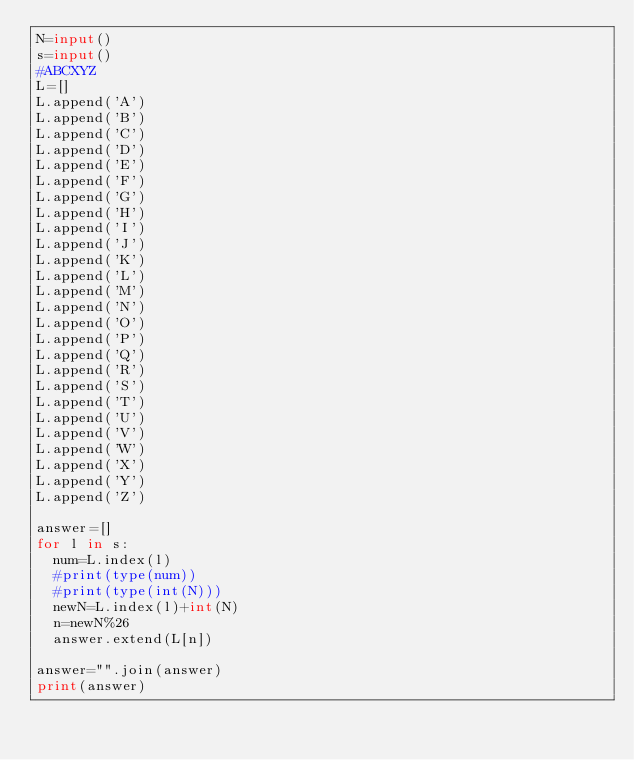<code> <loc_0><loc_0><loc_500><loc_500><_Python_>N=input()
s=input()
#ABCXYZ
L=[]
L.append('A')
L.append('B')
L.append('C')
L.append('D')
L.append('E')
L.append('F')
L.append('G')
L.append('H')
L.append('I')
L.append('J')
L.append('K')
L.append('L')
L.append('M')
L.append('N')
L.append('O')
L.append('P')
L.append('Q')
L.append('R')
L.append('S')
L.append('T')
L.append('U')
L.append('V')
L.append('W')
L.append('X')
L.append('Y')
L.append('Z')

answer=[]
for l in s:
  num=L.index(l)
  #print(type(num))
  #print(type(int(N)))
  newN=L.index(l)+int(N)
  n=newN%26
  answer.extend(L[n])  
  
answer="".join(answer)
print(answer)</code> 